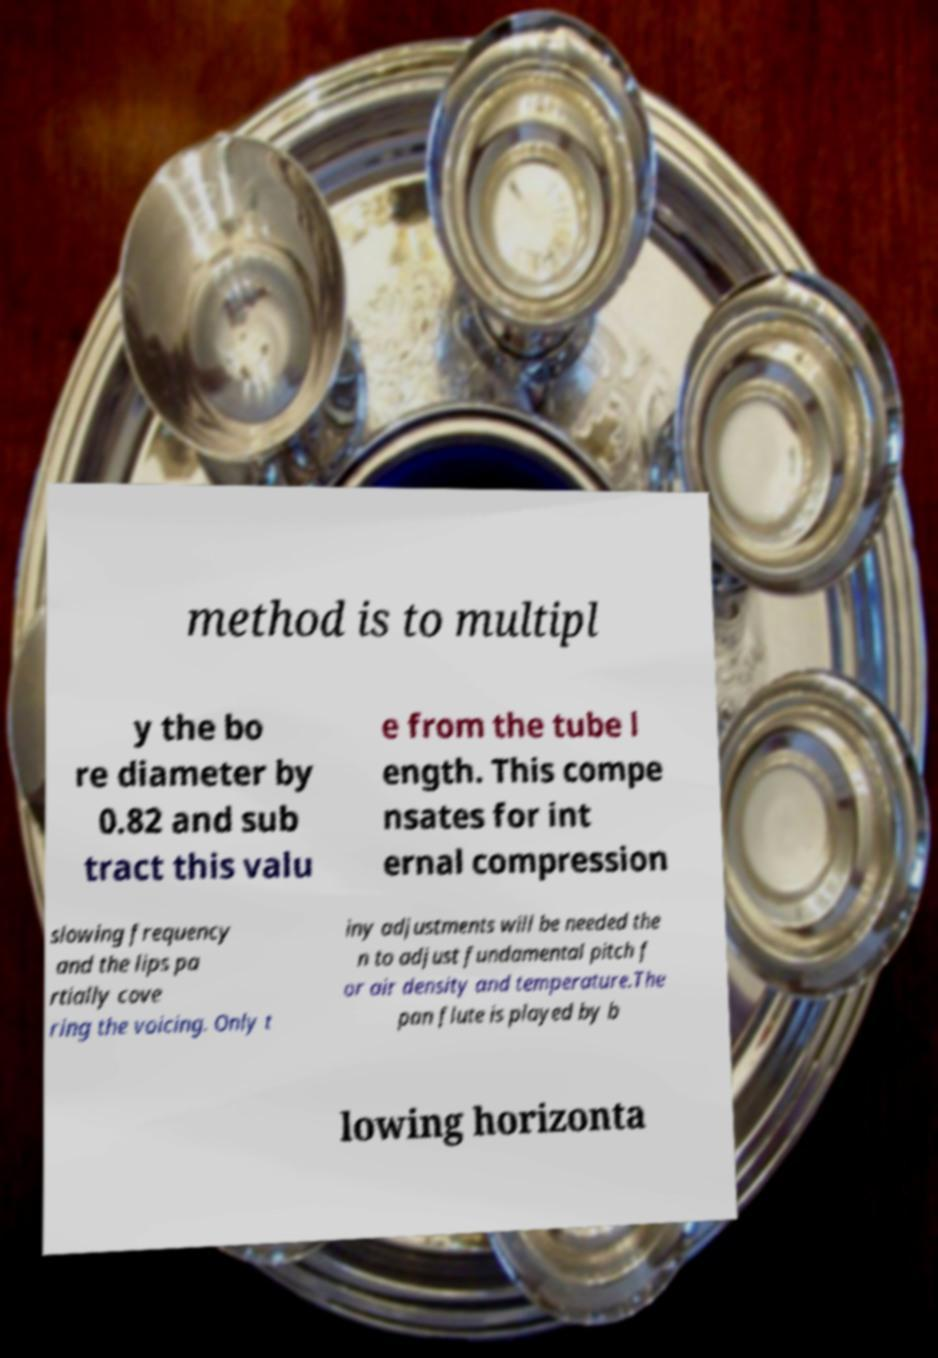Can you read and provide the text displayed in the image?This photo seems to have some interesting text. Can you extract and type it out for me? method is to multipl y the bo re diameter by 0.82 and sub tract this valu e from the tube l ength. This compe nsates for int ernal compression slowing frequency and the lips pa rtially cove ring the voicing. Only t iny adjustments will be needed the n to adjust fundamental pitch f or air density and temperature.The pan flute is played by b lowing horizonta 